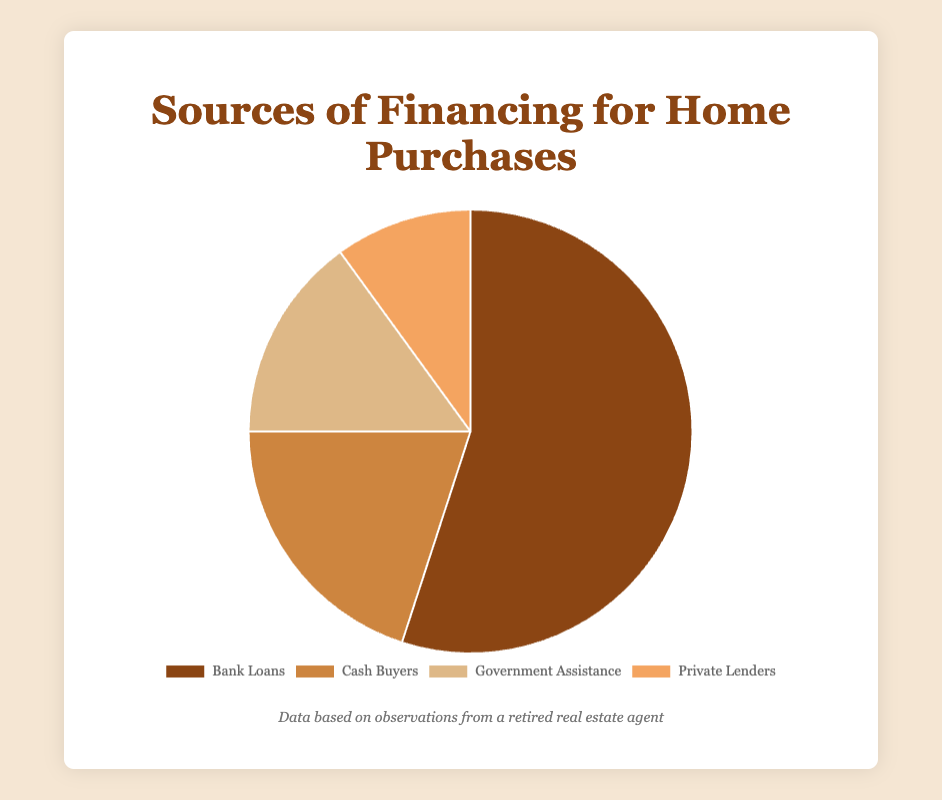What percentage of home purchases are financed by bank loans? The chart shows that the portion of the pie labeled 'Bank Loans' takes up 55% of the total pie.
Answer: 55% What is the difference in percentage between cash buyers and private lenders? Cash buyers occupy 20% of the pie chart, while private lenders occupy 10%. The difference is 20% - 10%.
Answer: 10% Which financing source contributes the least to home purchases? By looking at the pie chart, the smallest portion is labeled as 'Private Lenders,' which is 10% of the total.
Answer: Private Lenders What is the combined percentage of government assistance and private lenders? Government assistance is 15%, and private lenders are 10%. Combined, this makes 15% + 10%.
Answer: 25% Are there more homes purchased using government assistance or through cash buyers? The chart shows that 20% of homes are purchased by cash buyers while 15% are through government assistance, making cash buyers the higher group.
Answer: Cash Buyers What is the visual color representing government assistance in the pie chart? The pie section for government assistance is represented with a light brown color.
Answer: Light brown Is the percentage of homes financed by bank loans greater than the combined percentage of cash buyers and government assistance? Bank loans constitute 55%. Cash buyers take 20%, and government assistance takes 15%. Combined, cash buyers and government assistance are 20% + 15% = 35%. 55% is indeed greater than 35%.
Answer: Yes What is the percentage difference between the largest and smallest financing sources? Bank loans (55%) are the largest, and private lenders (10%) are the smallest. The difference is 55% - 10%.
Answer: 45% How many financing sources are there for home purchases according to the pie chart? The pie chart shows four distinct sections, each representing a different financing source.
Answer: Four 